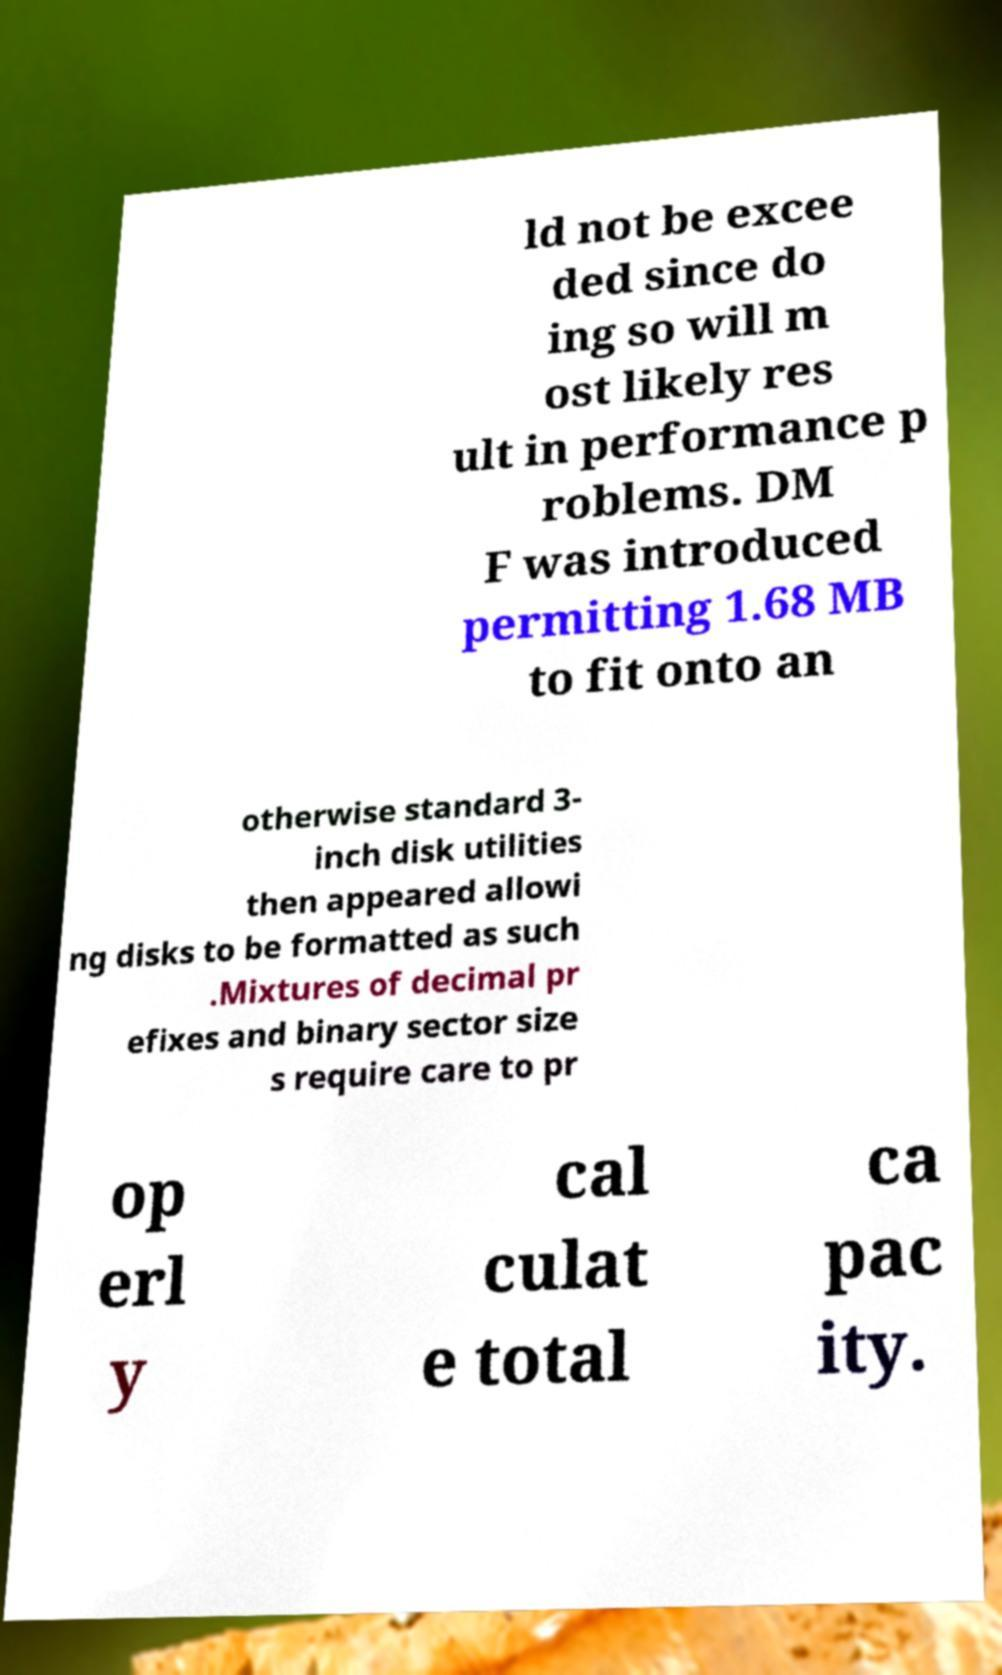Please read and relay the text visible in this image. What does it say? ld not be excee ded since do ing so will m ost likely res ult in performance p roblems. DM F was introduced permitting 1.68 MB to fit onto an otherwise standard 3- inch disk utilities then appeared allowi ng disks to be formatted as such .Mixtures of decimal pr efixes and binary sector size s require care to pr op erl y cal culat e total ca pac ity. 